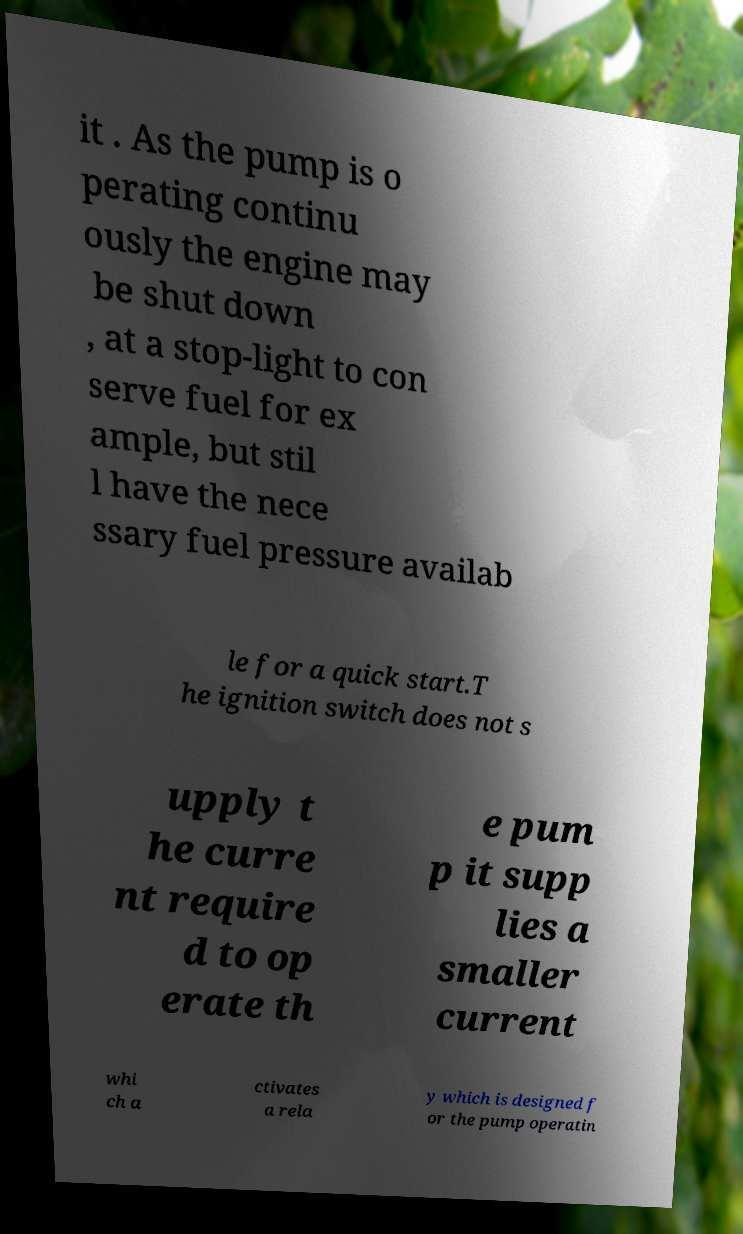I need the written content from this picture converted into text. Can you do that? it . As the pump is o perating continu ously the engine may be shut down , at a stop-light to con serve fuel for ex ample, but stil l have the nece ssary fuel pressure availab le for a quick start.T he ignition switch does not s upply t he curre nt require d to op erate th e pum p it supp lies a smaller current whi ch a ctivates a rela y which is designed f or the pump operatin 